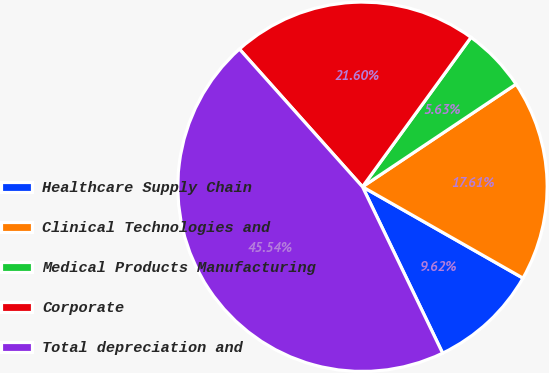Convert chart to OTSL. <chart><loc_0><loc_0><loc_500><loc_500><pie_chart><fcel>Healthcare Supply Chain<fcel>Clinical Technologies and<fcel>Medical Products Manufacturing<fcel>Corporate<fcel>Total depreciation and<nl><fcel>9.62%<fcel>17.61%<fcel>5.63%<fcel>21.6%<fcel>45.54%<nl></chart> 